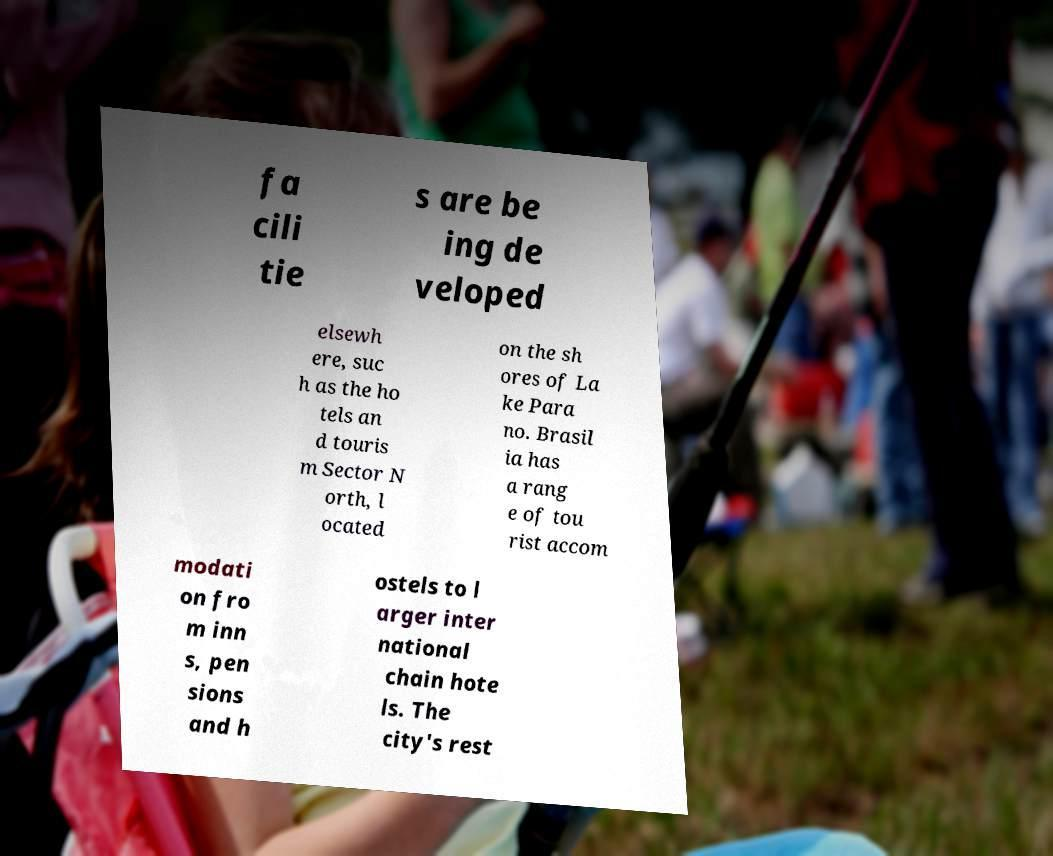Can you read and provide the text displayed in the image?This photo seems to have some interesting text. Can you extract and type it out for me? fa cili tie s are be ing de veloped elsewh ere, suc h as the ho tels an d touris m Sector N orth, l ocated on the sh ores of La ke Para no. Brasil ia has a rang e of tou rist accom modati on fro m inn s, pen sions and h ostels to l arger inter national chain hote ls. The city's rest 